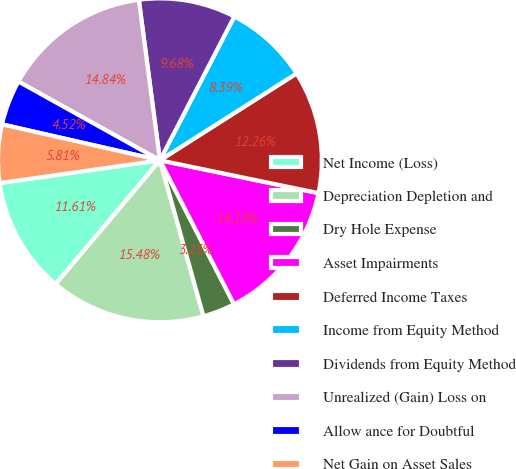Convert chart. <chart><loc_0><loc_0><loc_500><loc_500><pie_chart><fcel>Net Income (Loss)<fcel>Depreciation Depletion and<fcel>Dry Hole Expense<fcel>Asset Impairments<fcel>Deferred Income Taxes<fcel>Income from Equity Method<fcel>Dividends from Equity Method<fcel>Unrealized (Gain) Loss on<fcel>Allow ance for Doubtful<fcel>Net Gain on Asset Sales<nl><fcel>11.61%<fcel>15.48%<fcel>3.23%<fcel>14.19%<fcel>12.26%<fcel>8.39%<fcel>9.68%<fcel>14.84%<fcel>4.52%<fcel>5.81%<nl></chart> 